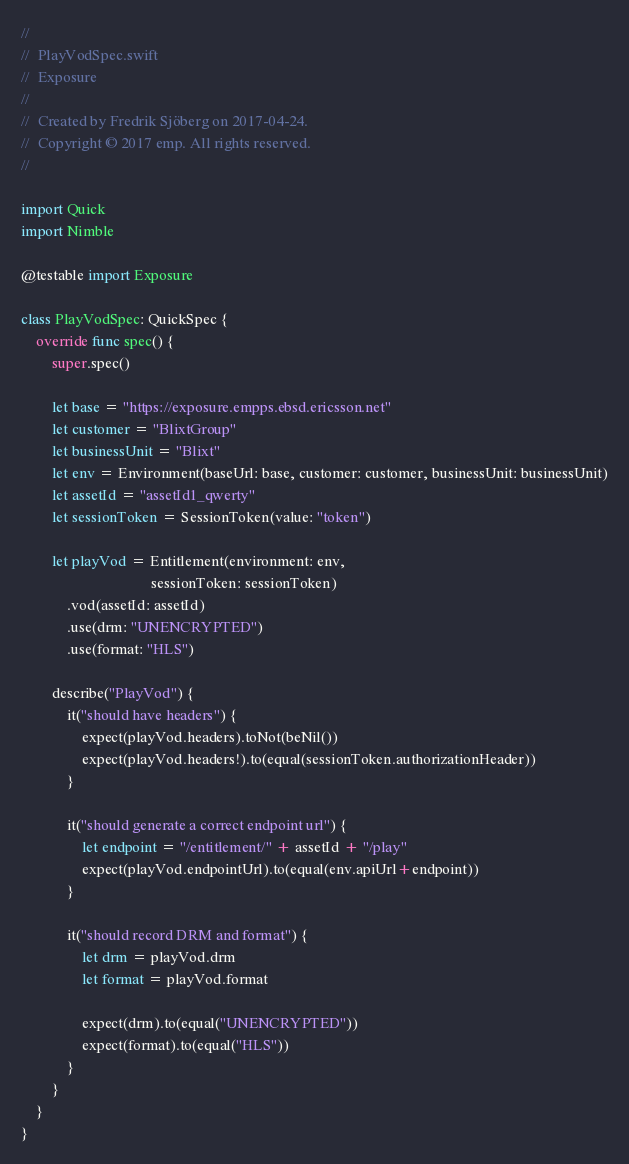Convert code to text. <code><loc_0><loc_0><loc_500><loc_500><_Swift_>//
//  PlayVodSpec.swift
//  Exposure
//
//  Created by Fredrik Sjöberg on 2017-04-24.
//  Copyright © 2017 emp. All rights reserved.
//

import Quick
import Nimble

@testable import Exposure

class PlayVodSpec: QuickSpec {
    override func spec() {
        super.spec()
        
        let base = "https://exposure.empps.ebsd.ericsson.net"
        let customer = "BlixtGroup"
        let businessUnit = "Blixt"
        let env = Environment(baseUrl: base, customer: customer, businessUnit: businessUnit)
        let assetId = "assetId1_qwerty"
        let sessionToken = SessionToken(value: "token")
        
        let playVod = Entitlement(environment: env,
                                  sessionToken: sessionToken)
            .vod(assetId: assetId)
            .use(drm: "UNENCRYPTED")
            .use(format: "HLS")
        
        describe("PlayVod") {
            it("should have headers") {
                expect(playVod.headers).toNot(beNil())
                expect(playVod.headers!).to(equal(sessionToken.authorizationHeader))
            }
            
            it("should generate a correct endpoint url") {
                let endpoint = "/entitlement/" + assetId + "/play"
                expect(playVod.endpointUrl).to(equal(env.apiUrl+endpoint))
            }
            
            it("should record DRM and format") {
                let drm = playVod.drm
                let format = playVod.format
                
                expect(drm).to(equal("UNENCRYPTED"))
                expect(format).to(equal("HLS"))
            }
        }
    }
}
</code> 